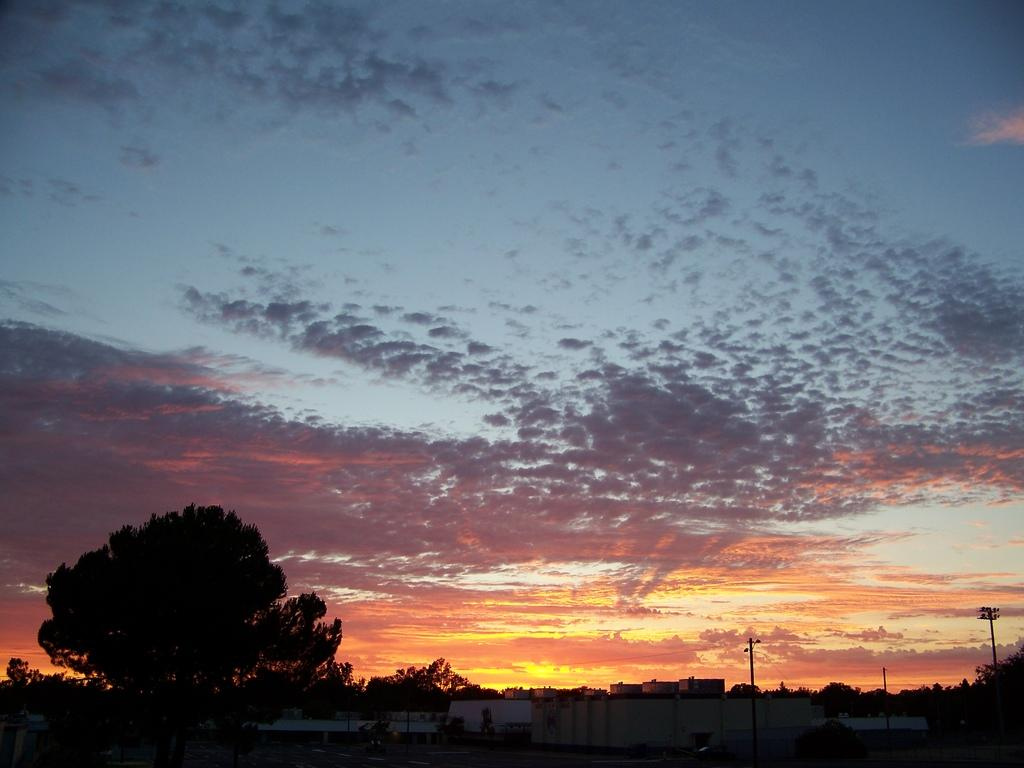What type of natural elements can be seen in the image? There are trees in the image. What man-made structures are present in the image? There are poles and buildings in the image. What is the condition of the sky in the image? The sky is cloudy in the image. How many dinosaurs can be seen in the image? There are no dinosaurs present in the image. What is the price of the linen featured in the image? There is no linen present in the image, so it is not possible to determine its price. 